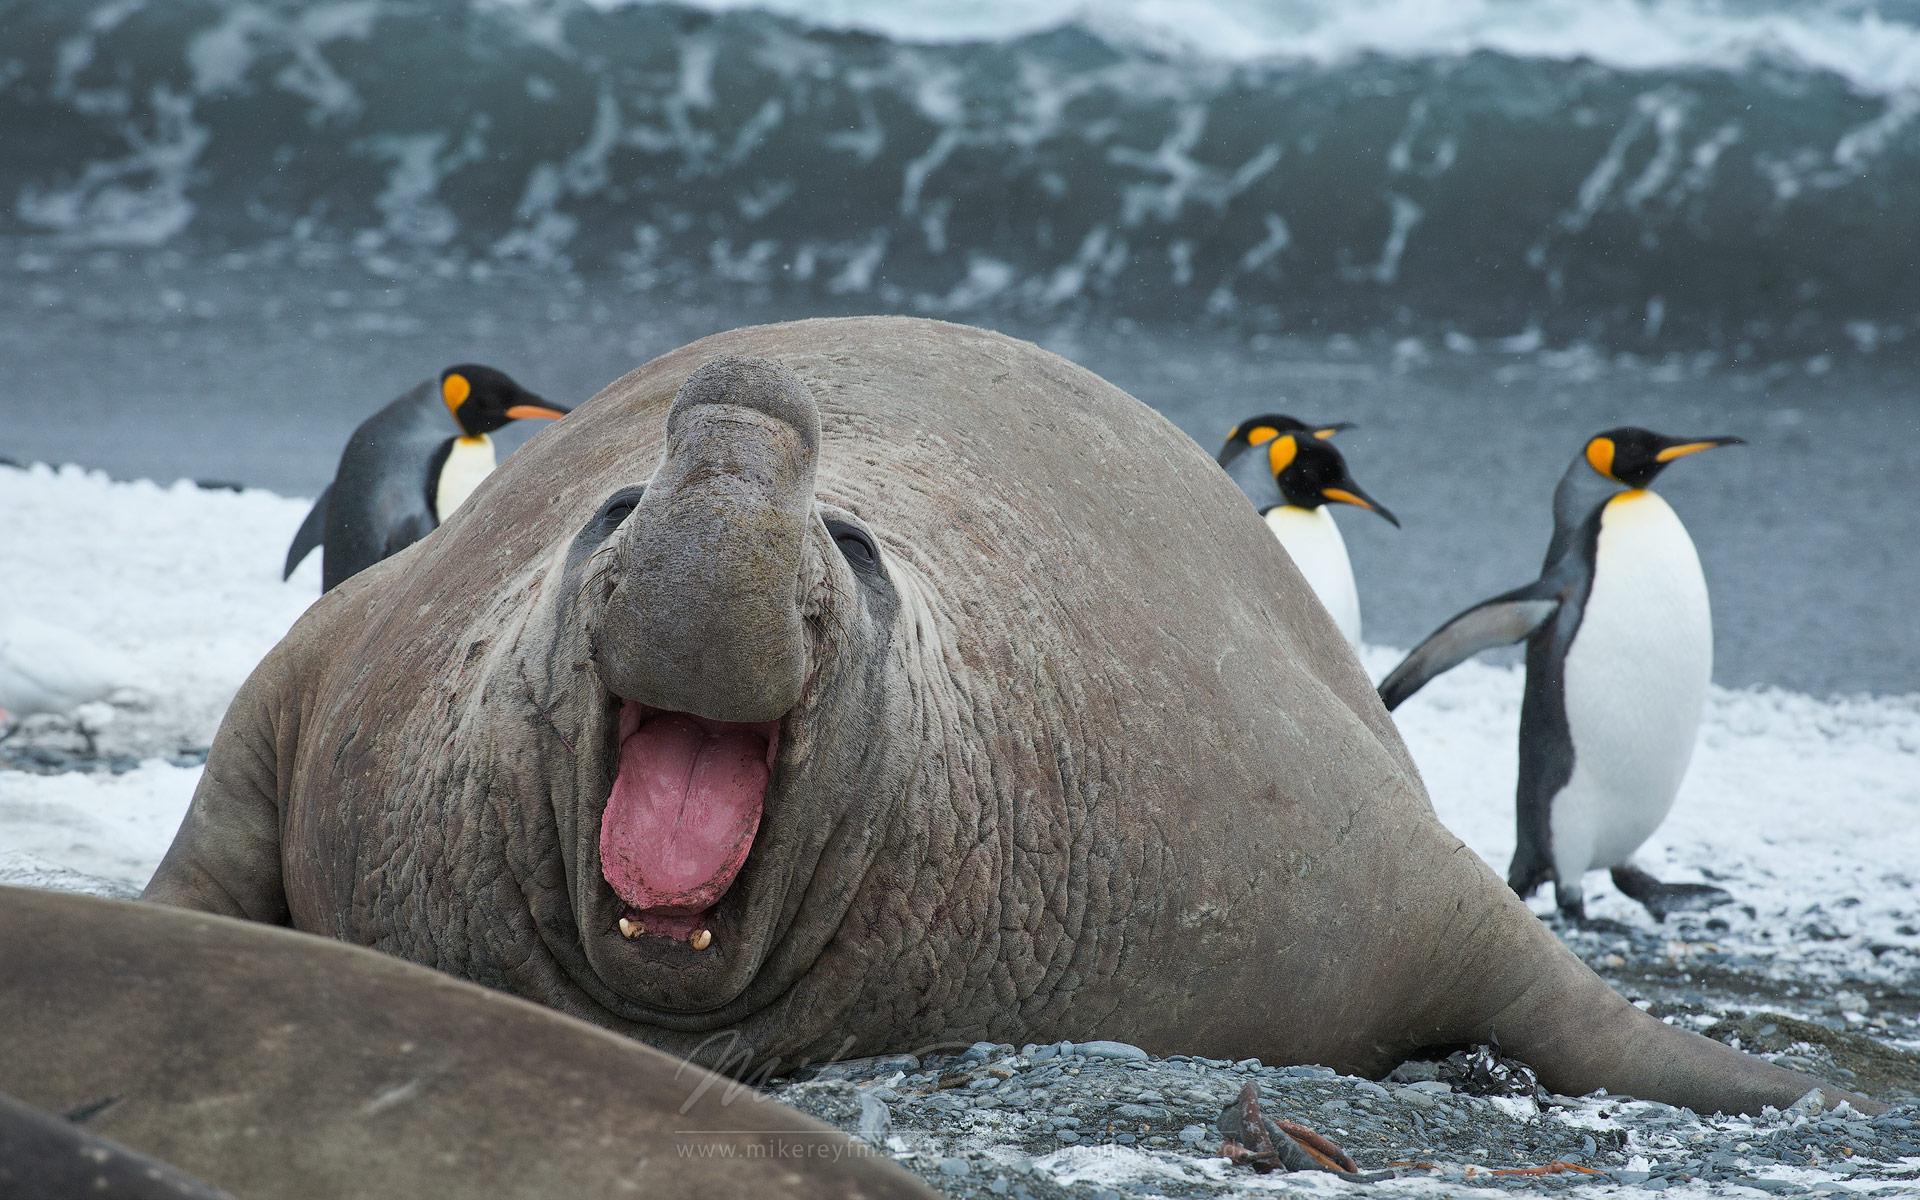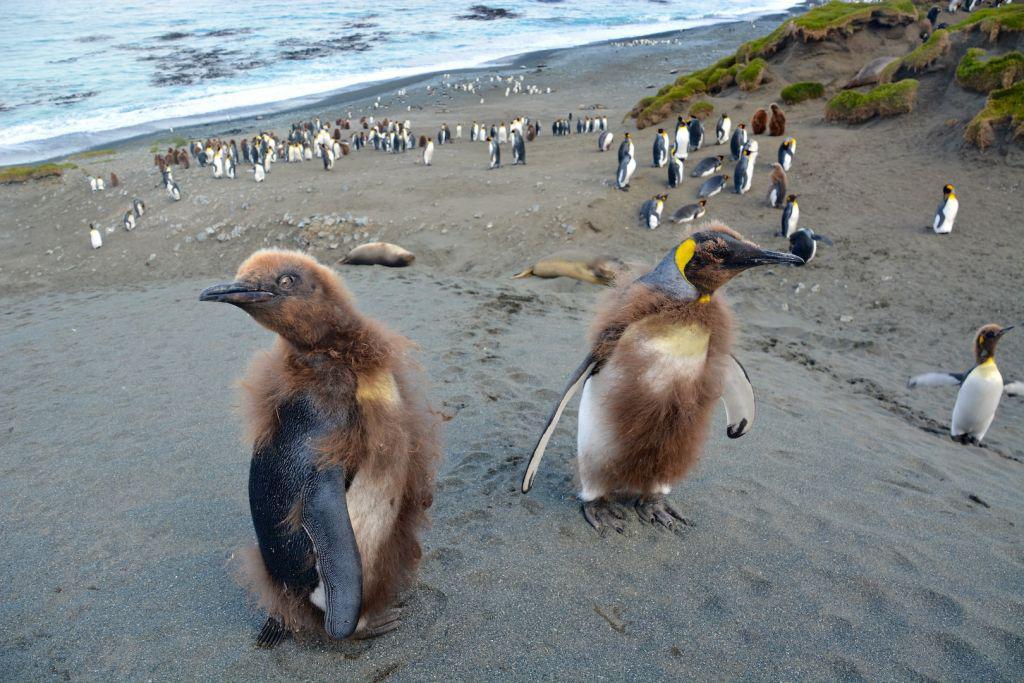The first image is the image on the left, the second image is the image on the right. For the images displayed, is the sentence "A single black and white penguin with yellow markings stands alone in the image on the left." factually correct? Answer yes or no. No. 